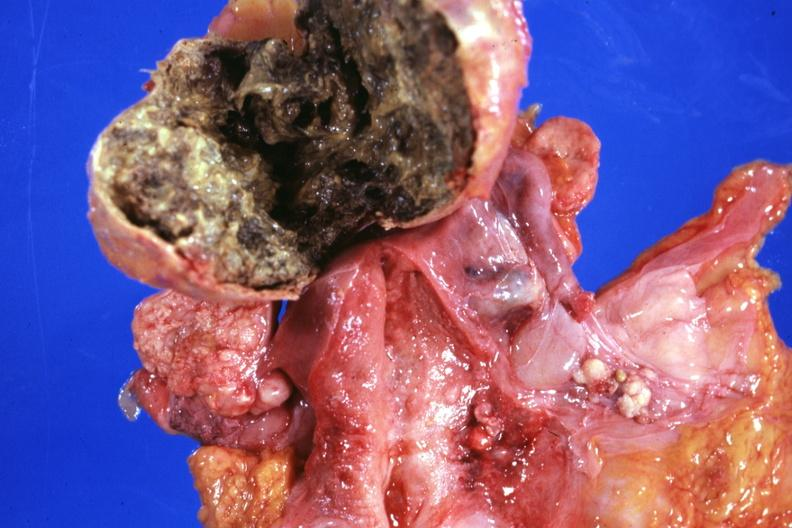does chromophobe adenoma show opened lesion with necrotic center not too typical?
Answer the question using a single word or phrase. No 